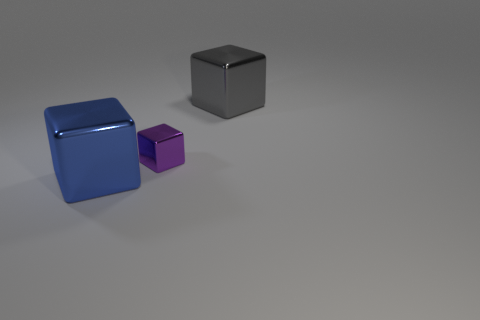Add 2 cubes. How many objects exist? 5 Add 2 big brown things. How many big brown things exist? 2 Subtract 0 blue cylinders. How many objects are left? 3 Subtract all tiny green objects. Subtract all metal objects. How many objects are left? 0 Add 1 large blue metal cubes. How many large blue metal cubes are left? 2 